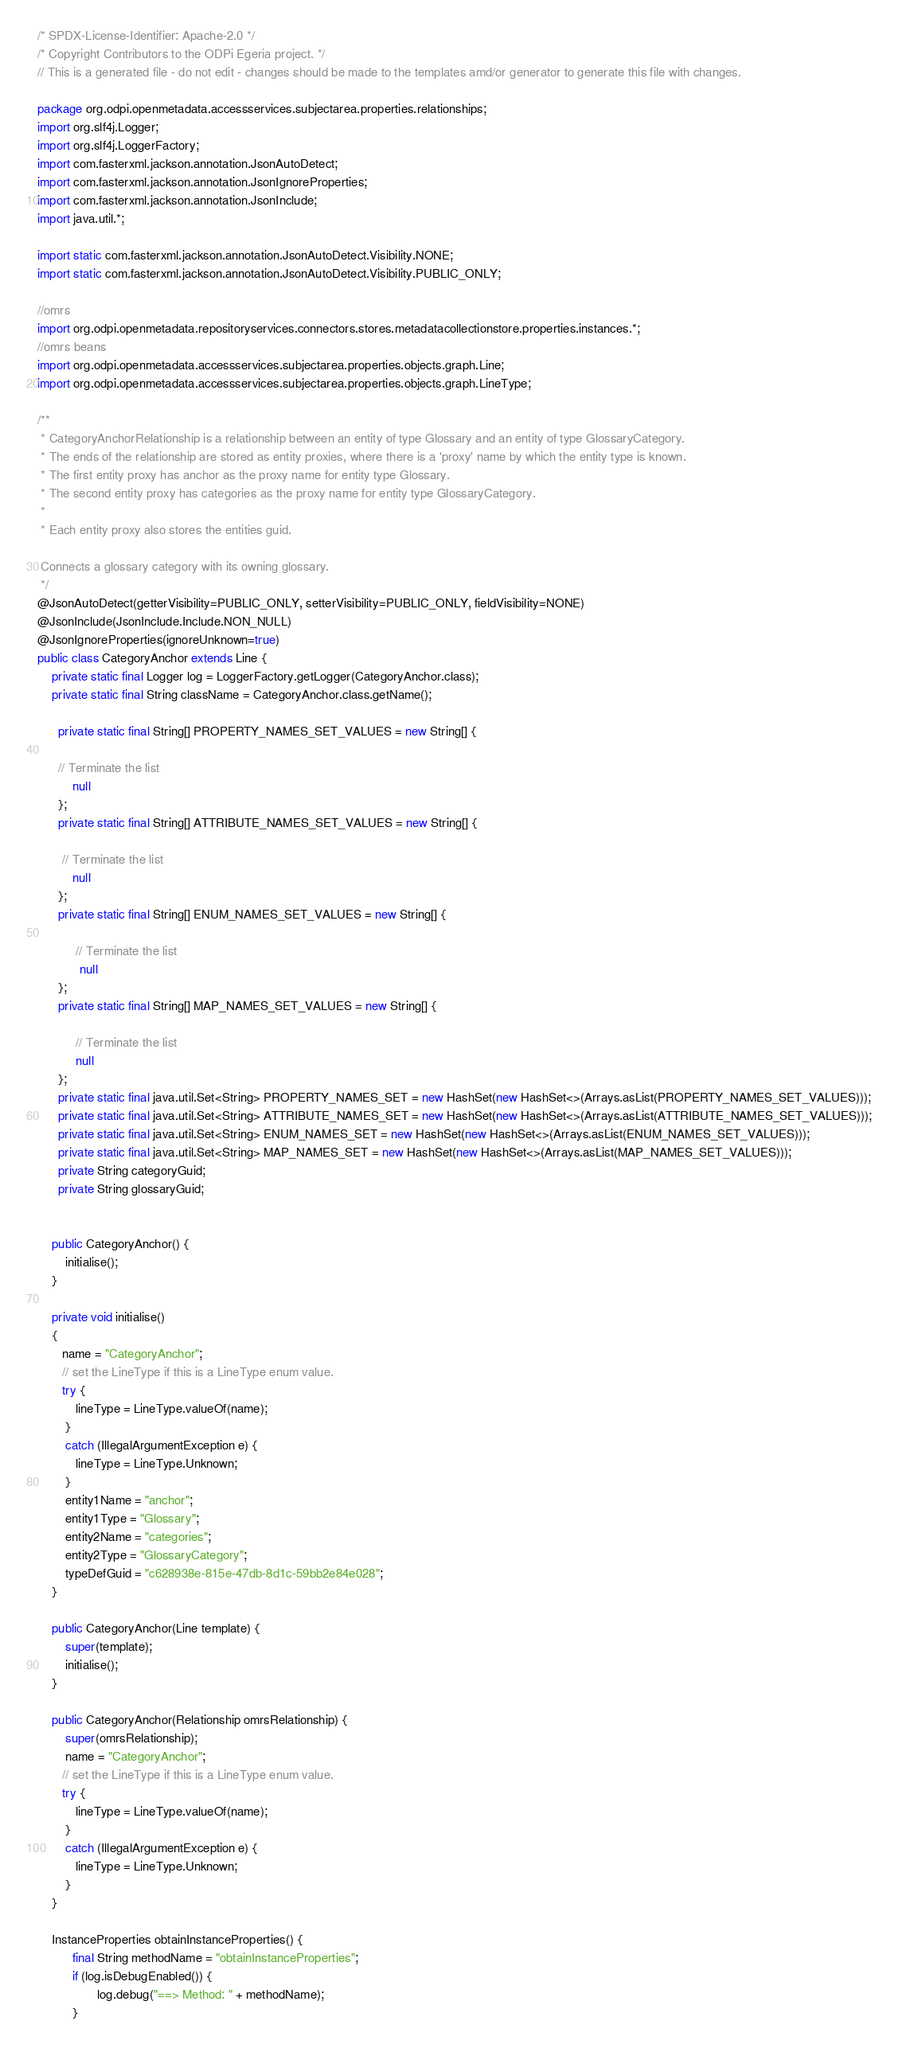<code> <loc_0><loc_0><loc_500><loc_500><_Java_>/* SPDX-License-Identifier: Apache-2.0 */
/* Copyright Contributors to the ODPi Egeria project. */
// This is a generated file - do not edit - changes should be made to the templates amd/or generator to generate this file with changes.

package org.odpi.openmetadata.accessservices.subjectarea.properties.relationships;
import org.slf4j.Logger;
import org.slf4j.LoggerFactory;
import com.fasterxml.jackson.annotation.JsonAutoDetect;
import com.fasterxml.jackson.annotation.JsonIgnoreProperties;
import com.fasterxml.jackson.annotation.JsonInclude;
import java.util.*;

import static com.fasterxml.jackson.annotation.JsonAutoDetect.Visibility.NONE;
import static com.fasterxml.jackson.annotation.JsonAutoDetect.Visibility.PUBLIC_ONLY;

//omrs
import org.odpi.openmetadata.repositoryservices.connectors.stores.metadatacollectionstore.properties.instances.*;
//omrs beans
import org.odpi.openmetadata.accessservices.subjectarea.properties.objects.graph.Line;
import org.odpi.openmetadata.accessservices.subjectarea.properties.objects.graph.LineType;

/**
 * CategoryAnchorRelationship is a relationship between an entity of type Glossary and an entity of type GlossaryCategory.
 * The ends of the relationship are stored as entity proxies, where there is a 'proxy' name by which the entity type is known.
 * The first entity proxy has anchor as the proxy name for entity type Glossary.
 * The second entity proxy has categories as the proxy name for entity type GlossaryCategory.
 *
 * Each entity proxy also stores the entities guid.

 Connects a glossary category with its owning glossary.
 */
@JsonAutoDetect(getterVisibility=PUBLIC_ONLY, setterVisibility=PUBLIC_ONLY, fieldVisibility=NONE)
@JsonInclude(JsonInclude.Include.NON_NULL)
@JsonIgnoreProperties(ignoreUnknown=true)
public class CategoryAnchor extends Line {
    private static final Logger log = LoggerFactory.getLogger(CategoryAnchor.class);
    private static final String className = CategoryAnchor.class.getName();

      private static final String[] PROPERTY_NAMES_SET_VALUES = new String[] {

      // Terminate the list
          null
      };
      private static final String[] ATTRIBUTE_NAMES_SET_VALUES = new String[] {

       // Terminate the list
          null
      };
      private static final String[] ENUM_NAMES_SET_VALUES = new String[] {

           // Terminate the list
            null
      };
      private static final String[] MAP_NAMES_SET_VALUES = new String[] {

           // Terminate the list
           null
      };
      private static final java.util.Set<String> PROPERTY_NAMES_SET = new HashSet(new HashSet<>(Arrays.asList(PROPERTY_NAMES_SET_VALUES)));
      private static final java.util.Set<String> ATTRIBUTE_NAMES_SET = new HashSet(new HashSet<>(Arrays.asList(ATTRIBUTE_NAMES_SET_VALUES)));
      private static final java.util.Set<String> ENUM_NAMES_SET = new HashSet(new HashSet<>(Arrays.asList(ENUM_NAMES_SET_VALUES)));
      private static final java.util.Set<String> MAP_NAMES_SET = new HashSet(new HashSet<>(Arrays.asList(MAP_NAMES_SET_VALUES)));
      private String categoryGuid;
      private String glossaryGuid;


    public CategoryAnchor() {
        initialise();
    }

    private void initialise()
    {
       name = "CategoryAnchor";
       // set the LineType if this is a LineType enum value.
       try {
           lineType = LineType.valueOf(name);
        }
        catch (IllegalArgumentException e) {
           lineType = LineType.Unknown;
        }
        entity1Name = "anchor";
        entity1Type = "Glossary";
        entity2Name = "categories";
        entity2Type = "GlossaryCategory";
        typeDefGuid = "c628938e-815e-47db-8d1c-59bb2e84e028";
    }

    public CategoryAnchor(Line template) {
        super(template);
        initialise();
    }

    public CategoryAnchor(Relationship omrsRelationship) {
        super(omrsRelationship);
        name = "CategoryAnchor";
       // set the LineType if this is a LineType enum value.
       try {
           lineType = LineType.valueOf(name);
        }
        catch (IllegalArgumentException e) {
           lineType = LineType.Unknown;
        }
    }

    InstanceProperties obtainInstanceProperties() {
          final String methodName = "obtainInstanceProperties";
          if (log.isDebugEnabled()) {
                 log.debug("==> Method: " + methodName);
          }</code> 